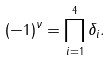<formula> <loc_0><loc_0><loc_500><loc_500>( - 1 ) ^ { \nu } = \prod _ { i = 1 } ^ { 4 } \delta _ { i } .</formula> 